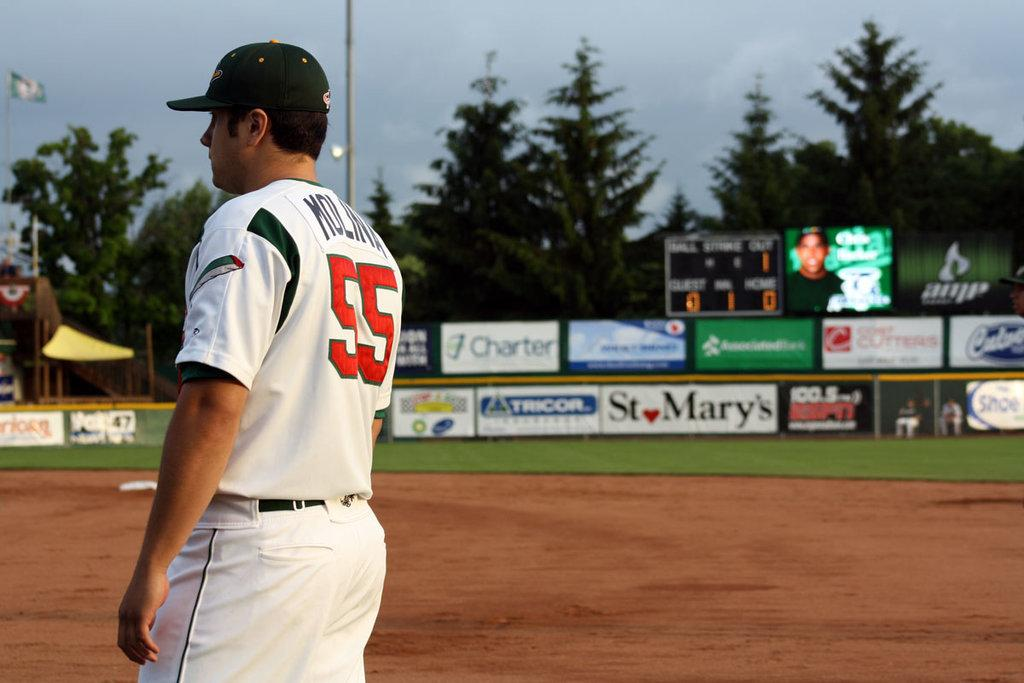Provide a one-sentence caption for the provided image. a boy playing baseball with the number 55 on his back. 